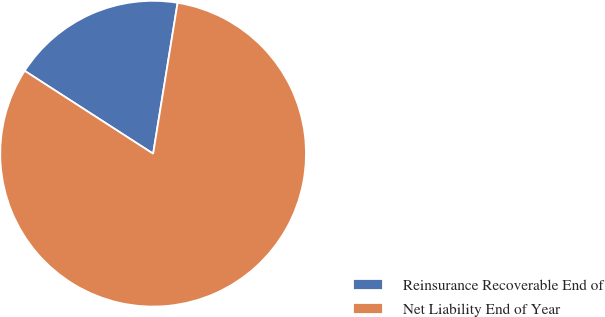Convert chart. <chart><loc_0><loc_0><loc_500><loc_500><pie_chart><fcel>Reinsurance Recoverable End of<fcel>Net Liability End of Year<nl><fcel>18.44%<fcel>81.56%<nl></chart> 